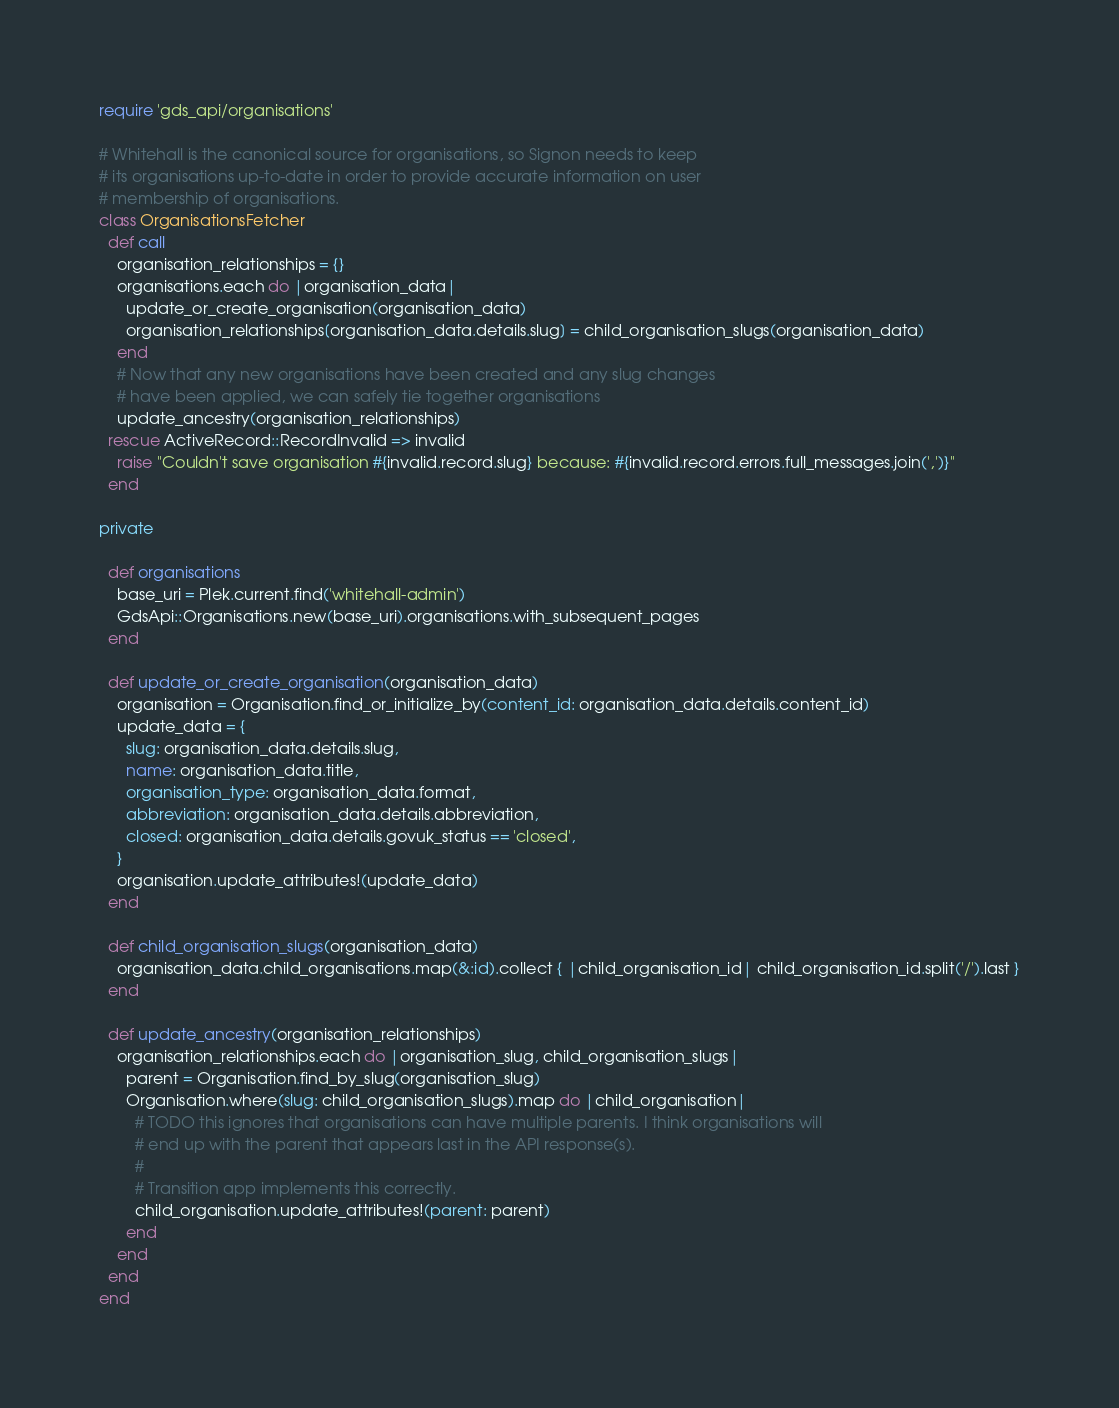<code> <loc_0><loc_0><loc_500><loc_500><_Ruby_>require 'gds_api/organisations'

# Whitehall is the canonical source for organisations, so Signon needs to keep
# its organisations up-to-date in order to provide accurate information on user
# membership of organisations.
class OrganisationsFetcher
  def call
    organisation_relationships = {}
    organisations.each do |organisation_data|
      update_or_create_organisation(organisation_data)
      organisation_relationships[organisation_data.details.slug] = child_organisation_slugs(organisation_data)
    end
    # Now that any new organisations have been created and any slug changes
    # have been applied, we can safely tie together organisations
    update_ancestry(organisation_relationships)
  rescue ActiveRecord::RecordInvalid => invalid
    raise "Couldn't save organisation #{invalid.record.slug} because: #{invalid.record.errors.full_messages.join(',')}"
  end

private

  def organisations
    base_uri = Plek.current.find('whitehall-admin')
    GdsApi::Organisations.new(base_uri).organisations.with_subsequent_pages
  end

  def update_or_create_organisation(organisation_data)
    organisation = Organisation.find_or_initialize_by(content_id: organisation_data.details.content_id)
    update_data = {
      slug: organisation_data.details.slug,
      name: organisation_data.title,
      organisation_type: organisation_data.format,
      abbreviation: organisation_data.details.abbreviation,
      closed: organisation_data.details.govuk_status == 'closed',
    }
    organisation.update_attributes!(update_data)
  end

  def child_organisation_slugs(organisation_data)
    organisation_data.child_organisations.map(&:id).collect { |child_organisation_id| child_organisation_id.split('/').last }
  end

  def update_ancestry(organisation_relationships)
    organisation_relationships.each do |organisation_slug, child_organisation_slugs|
      parent = Organisation.find_by_slug(organisation_slug)
      Organisation.where(slug: child_organisation_slugs).map do |child_organisation|
        # TODO this ignores that organisations can have multiple parents. I think organisations will
        # end up with the parent that appears last in the API response(s).
        #
        # Transition app implements this correctly.
        child_organisation.update_attributes!(parent: parent)
      end
    end
  end
end
</code> 